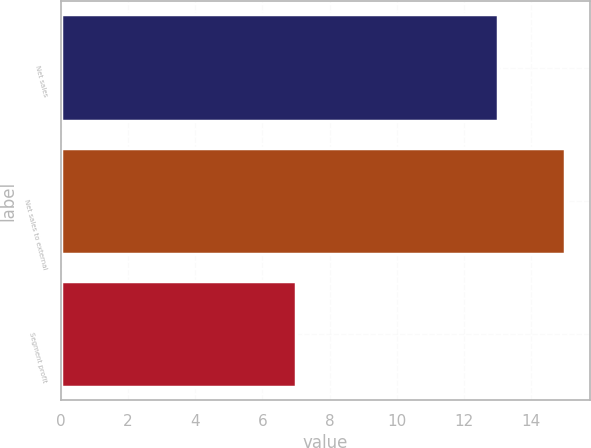Convert chart. <chart><loc_0><loc_0><loc_500><loc_500><bar_chart><fcel>Net sales<fcel>Net sales to external<fcel>Segment profit<nl><fcel>13<fcel>15<fcel>7<nl></chart> 